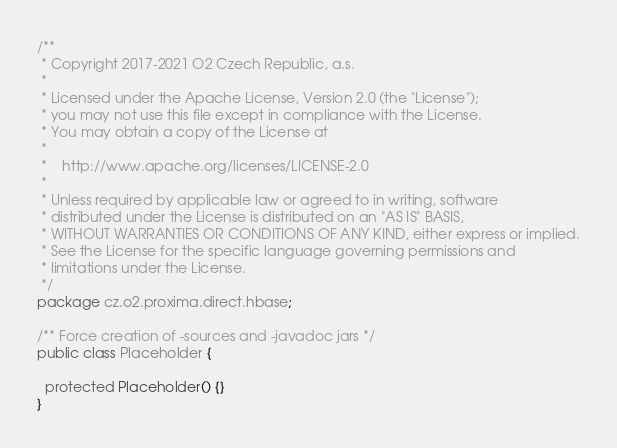Convert code to text. <code><loc_0><loc_0><loc_500><loc_500><_Java_>/**
 * Copyright 2017-2021 O2 Czech Republic, a.s.
 *
 * Licensed under the Apache License, Version 2.0 (the "License");
 * you may not use this file except in compliance with the License.
 * You may obtain a copy of the License at
 *
 *    http://www.apache.org/licenses/LICENSE-2.0
 *
 * Unless required by applicable law or agreed to in writing, software
 * distributed under the License is distributed on an "AS IS" BASIS,
 * WITHOUT WARRANTIES OR CONDITIONS OF ANY KIND, either express or implied.
 * See the License for the specific language governing permissions and
 * limitations under the License.
 */
package cz.o2.proxima.direct.hbase;

/** Force creation of -sources and -javadoc jars */
public class Placeholder {

  protected Placeholder() {}
}
</code> 